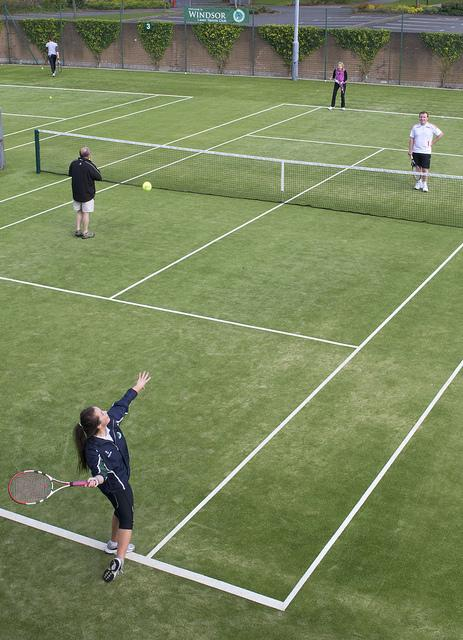What is the minimum number of players who can partake in a match of this sport?

Choices:
A) eight
B) four
C) two
D) three two 